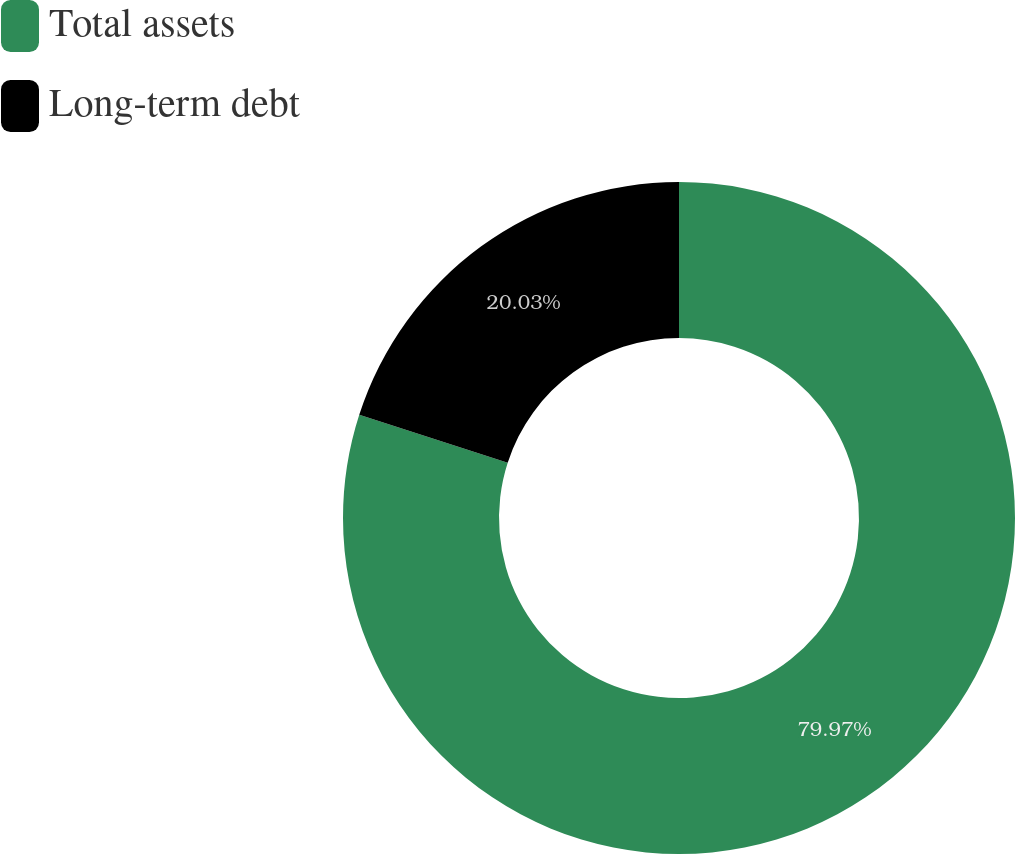Convert chart. <chart><loc_0><loc_0><loc_500><loc_500><pie_chart><fcel>Total assets<fcel>Long-term debt<nl><fcel>79.97%<fcel>20.03%<nl></chart> 